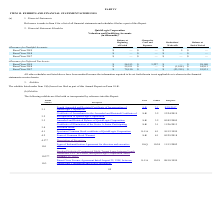From Quicklogic Corporation's financial document, What are the respective balance at the beginning of the period for fiscal year 2018 and 2019? The document shows two values: $55,931 and $54,913 (in thousands). From the document: "Fiscal Year 2018 $ 55,931 $ — $ (1,018 ) $ 54,913 Fiscal Year 2019 $ 54,913 $ 3,227 $ — $ 58,140..." Also, What are the respective balance at the end of the period for fiscal year 2018 and 2019? The document shows two values: $54,913 and $58,140 (in thousands). From the document: "Fiscal Year 2019 $ 54,913 $ 3,227 $ — $ 58,140 Fiscal Year 2019 $ 54,913 $ 3,227 $ — $ 58,140..." Also, What is the amount charged to costs and expenses in fiscal year 2019? According to the financial document, $3,227 (in thousands). The relevant text states: "Fiscal Year 2019 $ 54,913 $ 3,227 $ — $ 58,140..." Also, can you calculate: What is the total balance at the beginning of the period in fiscal year 2018 and 2019? Based on the calculation: $55,931 + $54,913 , the result is 110844 (in thousands). This is based on the information: "Fiscal Year 2019 $ 54,913 $ 3,227 $ — $ 58,140 Fiscal Year 2018 $ 55,931 $ — $ (1,018 ) $ 54,913..." The key data points involved are: 54,913, 55,931. Also, can you calculate: What is the average at the beginning of the period in fiscal year 2018 and 2019? To answer this question, I need to perform calculations using the financial data. The calculation is: ($55,931 + $54,913)/2 , which equals 55422 (in thousands). This is based on the information: "Fiscal Year 2019 $ 54,913 $ 3,227 $ — $ 58,140 Fiscal Year 2018 $ 55,931 $ — $ (1,018 ) $ 54,913..." The key data points involved are: 54,913, 55,931. Also, can you calculate: What is the value of the balance at the beginning of 2019 as a percentage of the balance at the end of 2019? Based on the calculation: $54,913/$58,140 , the result is 94.45 (percentage). This is based on the information: "Fiscal Year 2019 $ 54,913 $ 3,227 $ — $ 58,140 Fiscal Year 2019 $ 54,913 $ 3,227 $ — $ 58,140..." The key data points involved are: 54,913, 58,140. 